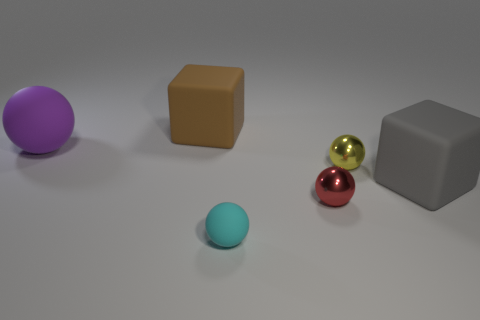What number of objects are cubes or balls behind the gray matte block?
Your answer should be very brief. 4. Is the number of rubber balls greater than the number of large red blocks?
Ensure brevity in your answer.  Yes. There is a large thing behind the large purple matte sphere; what is its shape?
Your answer should be very brief. Cube. What number of small red metal things are the same shape as the cyan matte thing?
Your response must be concise. 1. There is a rubber ball that is left of the tiny thing that is in front of the red metal ball; what size is it?
Your answer should be compact. Large. What number of cyan things are either matte spheres or tiny metallic objects?
Keep it short and to the point. 1. Is the number of matte balls in front of the yellow ball less than the number of small things that are in front of the large brown block?
Keep it short and to the point. Yes. Is the size of the red metallic ball the same as the gray rubber thing to the right of the small red metallic object?
Offer a very short reply. No. What number of purple matte balls are the same size as the purple rubber object?
Give a very brief answer. 0. What number of tiny things are purple rubber balls or cyan balls?
Provide a succinct answer. 1. 